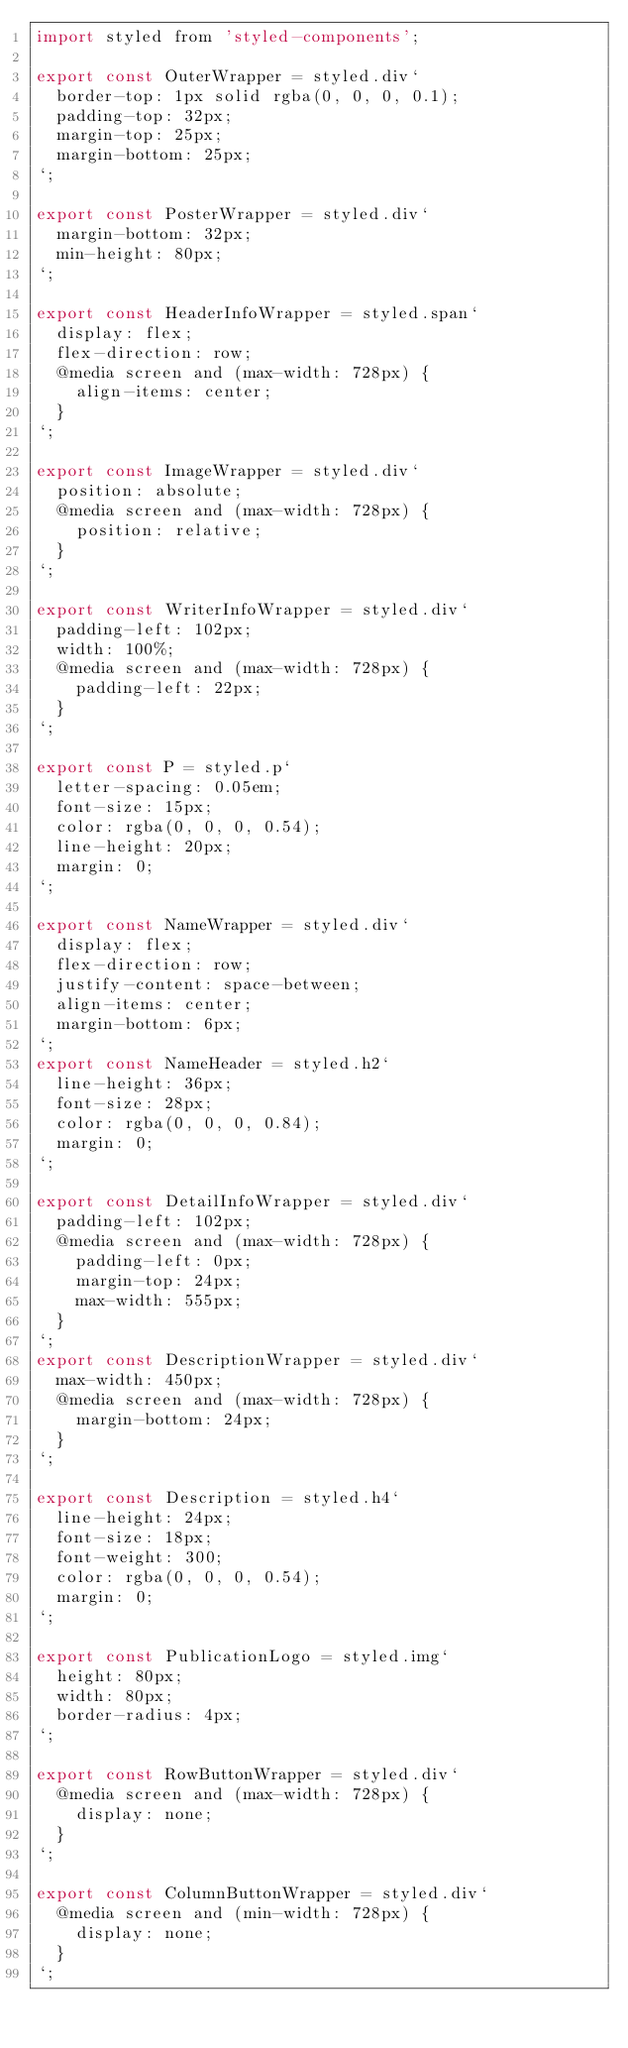<code> <loc_0><loc_0><loc_500><loc_500><_JavaScript_>import styled from 'styled-components';

export const OuterWrapper = styled.div`
  border-top: 1px solid rgba(0, 0, 0, 0.1);
  padding-top: 32px;
  margin-top: 25px;
  margin-bottom: 25px;
`;

export const PosterWrapper = styled.div`
  margin-bottom: 32px;
  min-height: 80px;
`;

export const HeaderInfoWrapper = styled.span`
  display: flex;
  flex-direction: row;
  @media screen and (max-width: 728px) {
    align-items: center;
  }
`;

export const ImageWrapper = styled.div`
  position: absolute;
  @media screen and (max-width: 728px) {
    position: relative;
  }
`;

export const WriterInfoWrapper = styled.div`
  padding-left: 102px;
  width: 100%;
  @media screen and (max-width: 728px) {
    padding-left: 22px;
  }
`;

export const P = styled.p`
  letter-spacing: 0.05em;
  font-size: 15px;
  color: rgba(0, 0, 0, 0.54);
  line-height: 20px;
  margin: 0;
`;

export const NameWrapper = styled.div`
  display: flex;
  flex-direction: row;
  justify-content: space-between;
  align-items: center;
  margin-bottom: 6px;
`;
export const NameHeader = styled.h2`
  line-height: 36px;
  font-size: 28px;
  color: rgba(0, 0, 0, 0.84);
  margin: 0;
`;

export const DetailInfoWrapper = styled.div`
  padding-left: 102px;
  @media screen and (max-width: 728px) {
    padding-left: 0px;
    margin-top: 24px;
    max-width: 555px;
  }
`;
export const DescriptionWrapper = styled.div`
  max-width: 450px;
  @media screen and (max-width: 728px) {
    margin-bottom: 24px;
  }
`;

export const Description = styled.h4`
  line-height: 24px;
  font-size: 18px;
  font-weight: 300;
  color: rgba(0, 0, 0, 0.54);
  margin: 0;
`;

export const PublicationLogo = styled.img`
  height: 80px;
  width: 80px;
  border-radius: 4px;
`;

export const RowButtonWrapper = styled.div`
  @media screen and (max-width: 728px) {
    display: none;
  }
`;

export const ColumnButtonWrapper = styled.div`
  @media screen and (min-width: 728px) {
    display: none;
  }
`;
</code> 